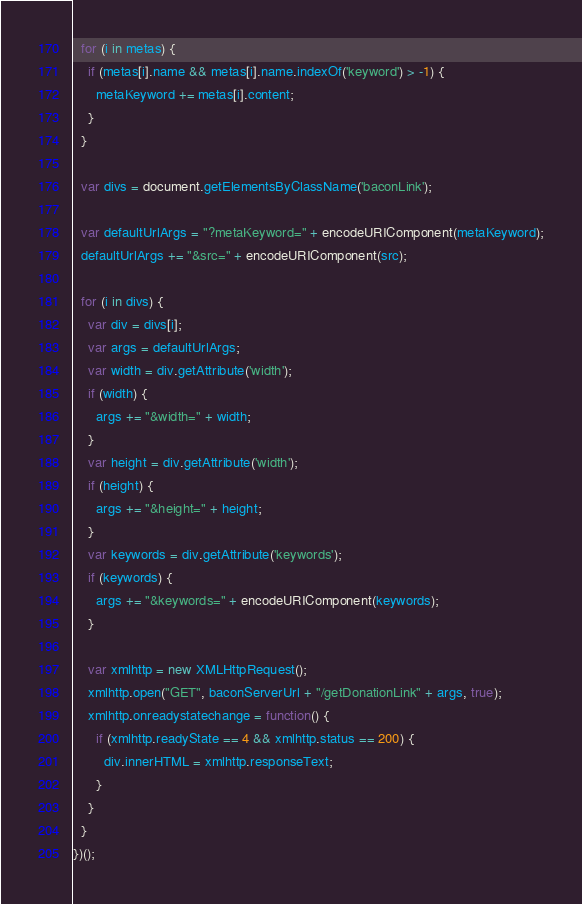Convert code to text. <code><loc_0><loc_0><loc_500><loc_500><_JavaScript_>  for (i in metas) {
    if (metas[i].name && metas[i].name.indexOf('keyword') > -1) {
      metaKeyword += metas[i].content;
    }
  }
  
  var divs = document.getElementsByClassName('baconLink');
  
  var defaultUrlArgs = "?metaKeyword=" + encodeURIComponent(metaKeyword);
  defaultUrlArgs += "&src=" + encodeURIComponent(src);
  
  for (i in divs) {
    var div = divs[i];
    var args = defaultUrlArgs;
    var width = div.getAttribute('width');
    if (width) {
      args += "&width=" + width;
    }
    var height = div.getAttribute('width');
    if (height) {
      args += "&height=" + height;
    }
    var keywords = div.getAttribute('keywords');
    if (keywords) {
      args += "&keywords=" + encodeURIComponent(keywords);
    }
    
    var xmlhttp = new XMLHttpRequest();
    xmlhttp.open("GET", baconServerUrl + "/getDonationLink" + args, true);
    xmlhttp.onreadystatechange = function() {
      if (xmlhttp.readyState == 4 && xmlhttp.status == 200) {
        div.innerHTML = xmlhttp.responseText;
      }
    }
  }
})();
</code> 